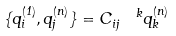Convert formula to latex. <formula><loc_0><loc_0><loc_500><loc_500>\{ q ^ { ( 1 ) } _ { i } , q ^ { ( n ) } _ { j } \} = C _ { i j } ^ { \ \ k } q ^ { ( n ) } _ { k }</formula> 